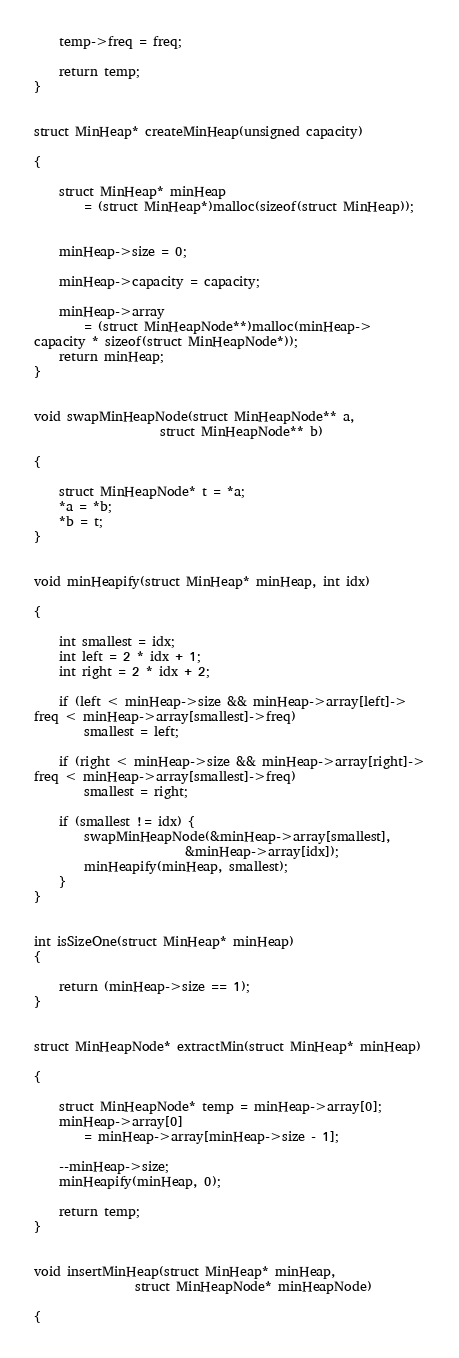Convert code to text. <code><loc_0><loc_0><loc_500><loc_500><_C++_>	temp->freq = freq;

	return temp;
}


struct MinHeap* createMinHeap(unsigned capacity)

{

	struct MinHeap* minHeap
		= (struct MinHeap*)malloc(sizeof(struct MinHeap));

	
	minHeap->size = 0;

	minHeap->capacity = capacity;

	minHeap->array
		= (struct MinHeapNode**)malloc(minHeap->
capacity * sizeof(struct MinHeapNode*));
	return minHeap;
}


void swapMinHeapNode(struct MinHeapNode** a,
					struct MinHeapNode** b)

{

	struct MinHeapNode* t = *a;
	*a = *b;
	*b = t;
}


void minHeapify(struct MinHeap* minHeap, int idx)

{

	int smallest = idx;
	int left = 2 * idx + 1;
	int right = 2 * idx + 2;

	if (left < minHeap->size && minHeap->array[left]->
freq < minHeap->array[smallest]->freq)
		smallest = left;

	if (right < minHeap->size && minHeap->array[right]->
freq < minHeap->array[smallest]->freq)
		smallest = right;

	if (smallest != idx) {
		swapMinHeapNode(&minHeap->array[smallest],
						&minHeap->array[idx]);
		minHeapify(minHeap, smallest);
	}
}


int isSizeOne(struct MinHeap* minHeap)
{

	return (minHeap->size == 1);
}


struct MinHeapNode* extractMin(struct MinHeap* minHeap)

{

	struct MinHeapNode* temp = minHeap->array[0];
	minHeap->array[0]
		= minHeap->array[minHeap->size - 1];

	--minHeap->size;
	minHeapify(minHeap, 0);

	return temp;
}


void insertMinHeap(struct MinHeap* minHeap,
				struct MinHeapNode* minHeapNode)

{
</code> 